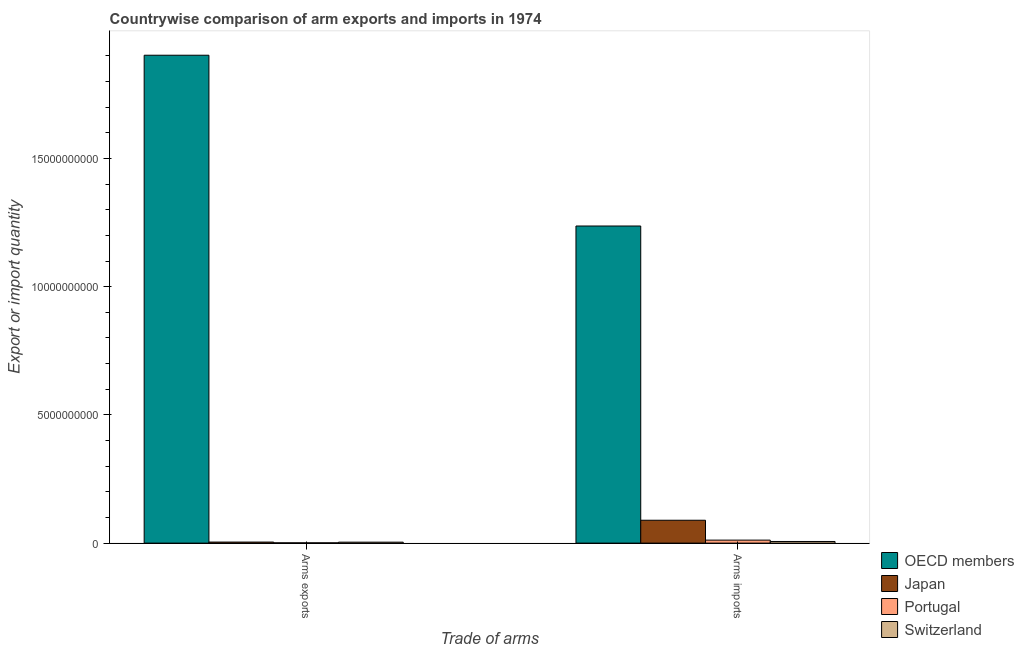How many groups of bars are there?
Your response must be concise. 2. Are the number of bars on each tick of the X-axis equal?
Keep it short and to the point. Yes. How many bars are there on the 1st tick from the left?
Make the answer very short. 4. How many bars are there on the 2nd tick from the right?
Offer a very short reply. 4. What is the label of the 2nd group of bars from the left?
Provide a succinct answer. Arms imports. What is the arms imports in OECD members?
Your answer should be very brief. 1.24e+1. Across all countries, what is the maximum arms exports?
Make the answer very short. 1.90e+1. Across all countries, what is the minimum arms exports?
Provide a succinct answer. 1.10e+07. In which country was the arms imports minimum?
Your response must be concise. Switzerland. What is the total arms imports in the graph?
Provide a short and direct response. 1.34e+1. What is the difference between the arms imports in Japan and that in OECD members?
Offer a very short reply. -1.15e+1. What is the difference between the arms exports in Switzerland and the arms imports in OECD members?
Make the answer very short. -1.23e+1. What is the average arms imports per country?
Give a very brief answer. 3.36e+09. What is the difference between the arms imports and arms exports in Switzerland?
Make the answer very short. 2.70e+07. What is the ratio of the arms exports in Switzerland to that in Japan?
Provide a succinct answer. 0.9. Is the arms exports in Switzerland less than that in Japan?
Offer a terse response. Yes. In how many countries, is the arms exports greater than the average arms exports taken over all countries?
Your response must be concise. 1. What does the 1st bar from the left in Arms exports represents?
Your answer should be very brief. OECD members. What does the 1st bar from the right in Arms imports represents?
Provide a short and direct response. Switzerland. Does the graph contain grids?
Keep it short and to the point. No. Where does the legend appear in the graph?
Provide a short and direct response. Bottom right. How many legend labels are there?
Make the answer very short. 4. What is the title of the graph?
Offer a terse response. Countrywise comparison of arm exports and imports in 1974. What is the label or title of the X-axis?
Keep it short and to the point. Trade of arms. What is the label or title of the Y-axis?
Provide a succinct answer. Export or import quantity. What is the Export or import quantity of OECD members in Arms exports?
Keep it short and to the point. 1.90e+1. What is the Export or import quantity in Japan in Arms exports?
Your answer should be very brief. 4.10e+07. What is the Export or import quantity in Portugal in Arms exports?
Provide a short and direct response. 1.10e+07. What is the Export or import quantity of Switzerland in Arms exports?
Your response must be concise. 3.70e+07. What is the Export or import quantity in OECD members in Arms imports?
Keep it short and to the point. 1.24e+1. What is the Export or import quantity of Japan in Arms imports?
Your response must be concise. 8.92e+08. What is the Export or import quantity in Portugal in Arms imports?
Provide a succinct answer. 1.17e+08. What is the Export or import quantity of Switzerland in Arms imports?
Provide a succinct answer. 6.40e+07. Across all Trade of arms, what is the maximum Export or import quantity of OECD members?
Ensure brevity in your answer.  1.90e+1. Across all Trade of arms, what is the maximum Export or import quantity in Japan?
Ensure brevity in your answer.  8.92e+08. Across all Trade of arms, what is the maximum Export or import quantity in Portugal?
Your response must be concise. 1.17e+08. Across all Trade of arms, what is the maximum Export or import quantity of Switzerland?
Provide a short and direct response. 6.40e+07. Across all Trade of arms, what is the minimum Export or import quantity in OECD members?
Ensure brevity in your answer.  1.24e+1. Across all Trade of arms, what is the minimum Export or import quantity of Japan?
Offer a terse response. 4.10e+07. Across all Trade of arms, what is the minimum Export or import quantity of Portugal?
Keep it short and to the point. 1.10e+07. Across all Trade of arms, what is the minimum Export or import quantity of Switzerland?
Ensure brevity in your answer.  3.70e+07. What is the total Export or import quantity of OECD members in the graph?
Give a very brief answer. 3.14e+1. What is the total Export or import quantity in Japan in the graph?
Ensure brevity in your answer.  9.33e+08. What is the total Export or import quantity in Portugal in the graph?
Make the answer very short. 1.28e+08. What is the total Export or import quantity in Switzerland in the graph?
Offer a terse response. 1.01e+08. What is the difference between the Export or import quantity of OECD members in Arms exports and that in Arms imports?
Your answer should be very brief. 6.66e+09. What is the difference between the Export or import quantity of Japan in Arms exports and that in Arms imports?
Your response must be concise. -8.51e+08. What is the difference between the Export or import quantity of Portugal in Arms exports and that in Arms imports?
Provide a short and direct response. -1.06e+08. What is the difference between the Export or import quantity of Switzerland in Arms exports and that in Arms imports?
Your response must be concise. -2.70e+07. What is the difference between the Export or import quantity in OECD members in Arms exports and the Export or import quantity in Japan in Arms imports?
Make the answer very short. 1.81e+1. What is the difference between the Export or import quantity in OECD members in Arms exports and the Export or import quantity in Portugal in Arms imports?
Make the answer very short. 1.89e+1. What is the difference between the Export or import quantity of OECD members in Arms exports and the Export or import quantity of Switzerland in Arms imports?
Your response must be concise. 1.90e+1. What is the difference between the Export or import quantity of Japan in Arms exports and the Export or import quantity of Portugal in Arms imports?
Your response must be concise. -7.60e+07. What is the difference between the Export or import quantity of Japan in Arms exports and the Export or import quantity of Switzerland in Arms imports?
Provide a short and direct response. -2.30e+07. What is the difference between the Export or import quantity of Portugal in Arms exports and the Export or import quantity of Switzerland in Arms imports?
Keep it short and to the point. -5.30e+07. What is the average Export or import quantity in OECD members per Trade of arms?
Your answer should be compact. 1.57e+1. What is the average Export or import quantity in Japan per Trade of arms?
Keep it short and to the point. 4.66e+08. What is the average Export or import quantity in Portugal per Trade of arms?
Offer a terse response. 6.40e+07. What is the average Export or import quantity in Switzerland per Trade of arms?
Give a very brief answer. 5.05e+07. What is the difference between the Export or import quantity of OECD members and Export or import quantity of Japan in Arms exports?
Give a very brief answer. 1.90e+1. What is the difference between the Export or import quantity in OECD members and Export or import quantity in Portugal in Arms exports?
Ensure brevity in your answer.  1.90e+1. What is the difference between the Export or import quantity in OECD members and Export or import quantity in Switzerland in Arms exports?
Your answer should be very brief. 1.90e+1. What is the difference between the Export or import quantity in Japan and Export or import quantity in Portugal in Arms exports?
Offer a very short reply. 3.00e+07. What is the difference between the Export or import quantity in Portugal and Export or import quantity in Switzerland in Arms exports?
Your response must be concise. -2.60e+07. What is the difference between the Export or import quantity of OECD members and Export or import quantity of Japan in Arms imports?
Give a very brief answer. 1.15e+1. What is the difference between the Export or import quantity in OECD members and Export or import quantity in Portugal in Arms imports?
Keep it short and to the point. 1.22e+1. What is the difference between the Export or import quantity of OECD members and Export or import quantity of Switzerland in Arms imports?
Ensure brevity in your answer.  1.23e+1. What is the difference between the Export or import quantity in Japan and Export or import quantity in Portugal in Arms imports?
Offer a very short reply. 7.75e+08. What is the difference between the Export or import quantity of Japan and Export or import quantity of Switzerland in Arms imports?
Ensure brevity in your answer.  8.28e+08. What is the difference between the Export or import quantity of Portugal and Export or import quantity of Switzerland in Arms imports?
Your answer should be compact. 5.30e+07. What is the ratio of the Export or import quantity in OECD members in Arms exports to that in Arms imports?
Your answer should be very brief. 1.54. What is the ratio of the Export or import quantity in Japan in Arms exports to that in Arms imports?
Give a very brief answer. 0.05. What is the ratio of the Export or import quantity in Portugal in Arms exports to that in Arms imports?
Make the answer very short. 0.09. What is the ratio of the Export or import quantity of Switzerland in Arms exports to that in Arms imports?
Offer a very short reply. 0.58. What is the difference between the highest and the second highest Export or import quantity of OECD members?
Your response must be concise. 6.66e+09. What is the difference between the highest and the second highest Export or import quantity in Japan?
Your answer should be compact. 8.51e+08. What is the difference between the highest and the second highest Export or import quantity of Portugal?
Ensure brevity in your answer.  1.06e+08. What is the difference between the highest and the second highest Export or import quantity in Switzerland?
Your answer should be very brief. 2.70e+07. What is the difference between the highest and the lowest Export or import quantity of OECD members?
Keep it short and to the point. 6.66e+09. What is the difference between the highest and the lowest Export or import quantity of Japan?
Your response must be concise. 8.51e+08. What is the difference between the highest and the lowest Export or import quantity in Portugal?
Provide a short and direct response. 1.06e+08. What is the difference between the highest and the lowest Export or import quantity in Switzerland?
Your answer should be compact. 2.70e+07. 